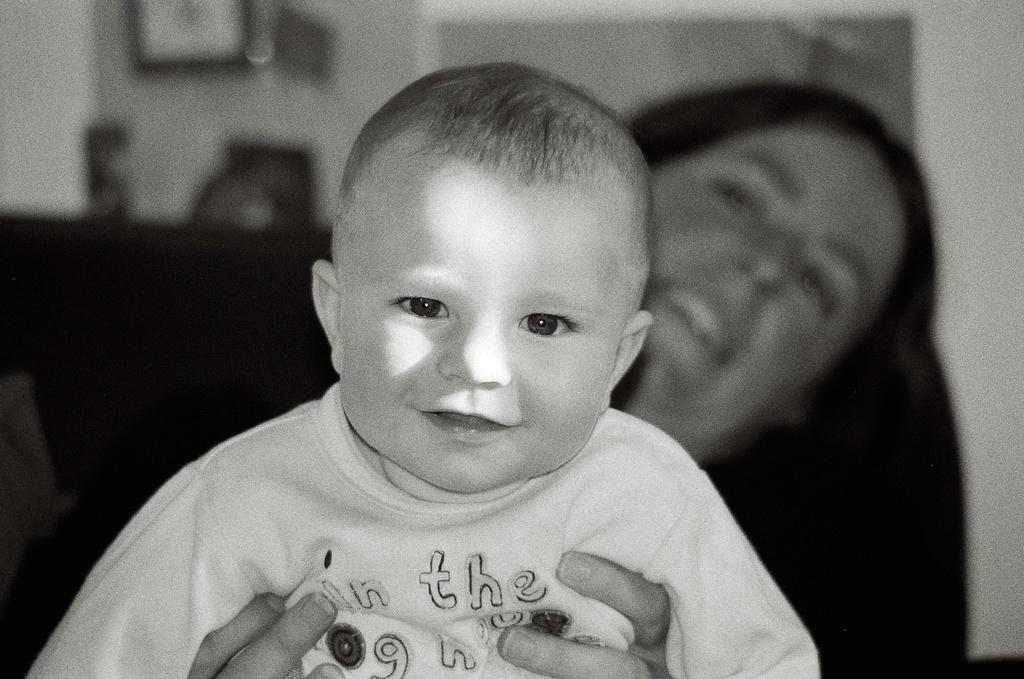Who is the main subject in the image? There is a woman in the image. What is the woman doing in the image? The woman is holding a boy. What is the purpose of the toad in the image? There is no toad present in the image, so it cannot serve any purpose. 